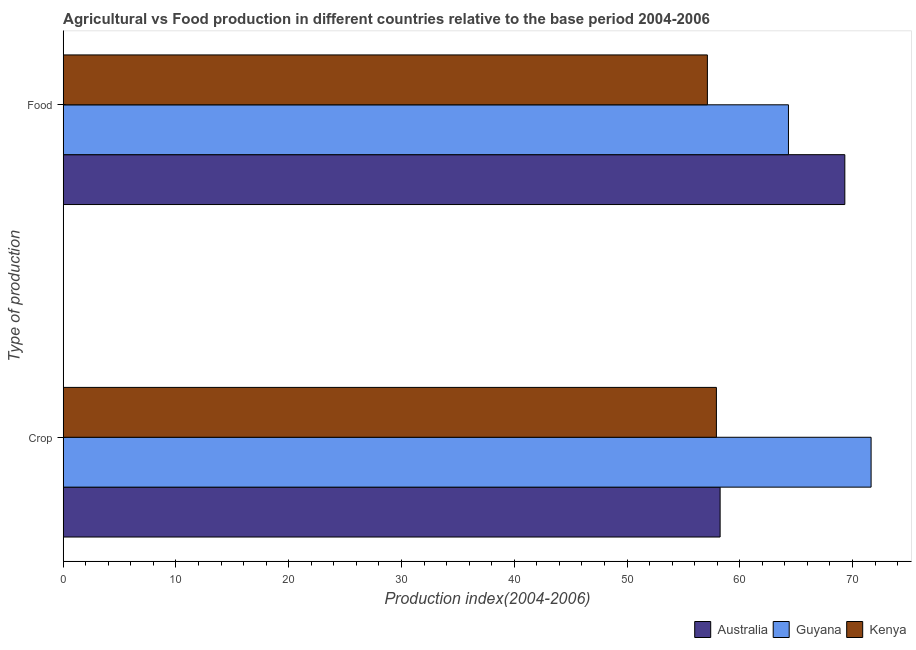How many groups of bars are there?
Provide a short and direct response. 2. Are the number of bars on each tick of the Y-axis equal?
Ensure brevity in your answer.  Yes. What is the label of the 2nd group of bars from the top?
Your response must be concise. Crop. What is the crop production index in Australia?
Give a very brief answer. 58.26. Across all countries, what is the maximum food production index?
Your answer should be very brief. 69.32. Across all countries, what is the minimum crop production index?
Your response must be concise. 57.93. In which country was the food production index maximum?
Your response must be concise. Australia. In which country was the crop production index minimum?
Provide a succinct answer. Kenya. What is the total food production index in the graph?
Ensure brevity in your answer.  190.77. What is the difference between the crop production index in Guyana and that in Kenya?
Make the answer very short. 13.72. What is the difference between the food production index in Australia and the crop production index in Guyana?
Offer a very short reply. -2.33. What is the average food production index per country?
Make the answer very short. 63.59. What is the difference between the crop production index and food production index in Australia?
Your answer should be very brief. -11.06. What is the ratio of the crop production index in Guyana to that in Australia?
Keep it short and to the point. 1.23. What does the 3rd bar from the top in Food represents?
Your answer should be very brief. Australia. What does the 3rd bar from the bottom in Food represents?
Ensure brevity in your answer.  Kenya. Are all the bars in the graph horizontal?
Give a very brief answer. Yes. How many countries are there in the graph?
Your answer should be very brief. 3. Are the values on the major ticks of X-axis written in scientific E-notation?
Your response must be concise. No. Does the graph contain any zero values?
Offer a terse response. No. What is the title of the graph?
Offer a very short reply. Agricultural vs Food production in different countries relative to the base period 2004-2006. Does "Lithuania" appear as one of the legend labels in the graph?
Offer a terse response. No. What is the label or title of the X-axis?
Make the answer very short. Production index(2004-2006). What is the label or title of the Y-axis?
Keep it short and to the point. Type of production. What is the Production index(2004-2006) in Australia in Crop?
Offer a terse response. 58.26. What is the Production index(2004-2006) in Guyana in Crop?
Make the answer very short. 71.65. What is the Production index(2004-2006) of Kenya in Crop?
Your response must be concise. 57.93. What is the Production index(2004-2006) in Australia in Food?
Make the answer very short. 69.32. What is the Production index(2004-2006) in Guyana in Food?
Your response must be concise. 64.32. What is the Production index(2004-2006) in Kenya in Food?
Offer a terse response. 57.13. Across all Type of production, what is the maximum Production index(2004-2006) in Australia?
Your answer should be compact. 69.32. Across all Type of production, what is the maximum Production index(2004-2006) in Guyana?
Offer a very short reply. 71.65. Across all Type of production, what is the maximum Production index(2004-2006) in Kenya?
Provide a short and direct response. 57.93. Across all Type of production, what is the minimum Production index(2004-2006) of Australia?
Offer a terse response. 58.26. Across all Type of production, what is the minimum Production index(2004-2006) of Guyana?
Offer a very short reply. 64.32. Across all Type of production, what is the minimum Production index(2004-2006) of Kenya?
Give a very brief answer. 57.13. What is the total Production index(2004-2006) of Australia in the graph?
Offer a terse response. 127.58. What is the total Production index(2004-2006) of Guyana in the graph?
Your answer should be very brief. 135.97. What is the total Production index(2004-2006) in Kenya in the graph?
Keep it short and to the point. 115.06. What is the difference between the Production index(2004-2006) in Australia in Crop and that in Food?
Ensure brevity in your answer.  -11.06. What is the difference between the Production index(2004-2006) of Guyana in Crop and that in Food?
Provide a short and direct response. 7.33. What is the difference between the Production index(2004-2006) of Australia in Crop and the Production index(2004-2006) of Guyana in Food?
Offer a very short reply. -6.06. What is the difference between the Production index(2004-2006) in Australia in Crop and the Production index(2004-2006) in Kenya in Food?
Keep it short and to the point. 1.13. What is the difference between the Production index(2004-2006) in Guyana in Crop and the Production index(2004-2006) in Kenya in Food?
Keep it short and to the point. 14.52. What is the average Production index(2004-2006) of Australia per Type of production?
Make the answer very short. 63.79. What is the average Production index(2004-2006) of Guyana per Type of production?
Offer a very short reply. 67.98. What is the average Production index(2004-2006) of Kenya per Type of production?
Give a very brief answer. 57.53. What is the difference between the Production index(2004-2006) of Australia and Production index(2004-2006) of Guyana in Crop?
Offer a very short reply. -13.39. What is the difference between the Production index(2004-2006) in Australia and Production index(2004-2006) in Kenya in Crop?
Keep it short and to the point. 0.33. What is the difference between the Production index(2004-2006) in Guyana and Production index(2004-2006) in Kenya in Crop?
Keep it short and to the point. 13.72. What is the difference between the Production index(2004-2006) of Australia and Production index(2004-2006) of Kenya in Food?
Ensure brevity in your answer.  12.19. What is the difference between the Production index(2004-2006) in Guyana and Production index(2004-2006) in Kenya in Food?
Your answer should be very brief. 7.19. What is the ratio of the Production index(2004-2006) of Australia in Crop to that in Food?
Provide a short and direct response. 0.84. What is the ratio of the Production index(2004-2006) in Guyana in Crop to that in Food?
Make the answer very short. 1.11. What is the difference between the highest and the second highest Production index(2004-2006) of Australia?
Your response must be concise. 11.06. What is the difference between the highest and the second highest Production index(2004-2006) of Guyana?
Make the answer very short. 7.33. What is the difference between the highest and the second highest Production index(2004-2006) of Kenya?
Keep it short and to the point. 0.8. What is the difference between the highest and the lowest Production index(2004-2006) of Australia?
Your response must be concise. 11.06. What is the difference between the highest and the lowest Production index(2004-2006) in Guyana?
Provide a short and direct response. 7.33. 